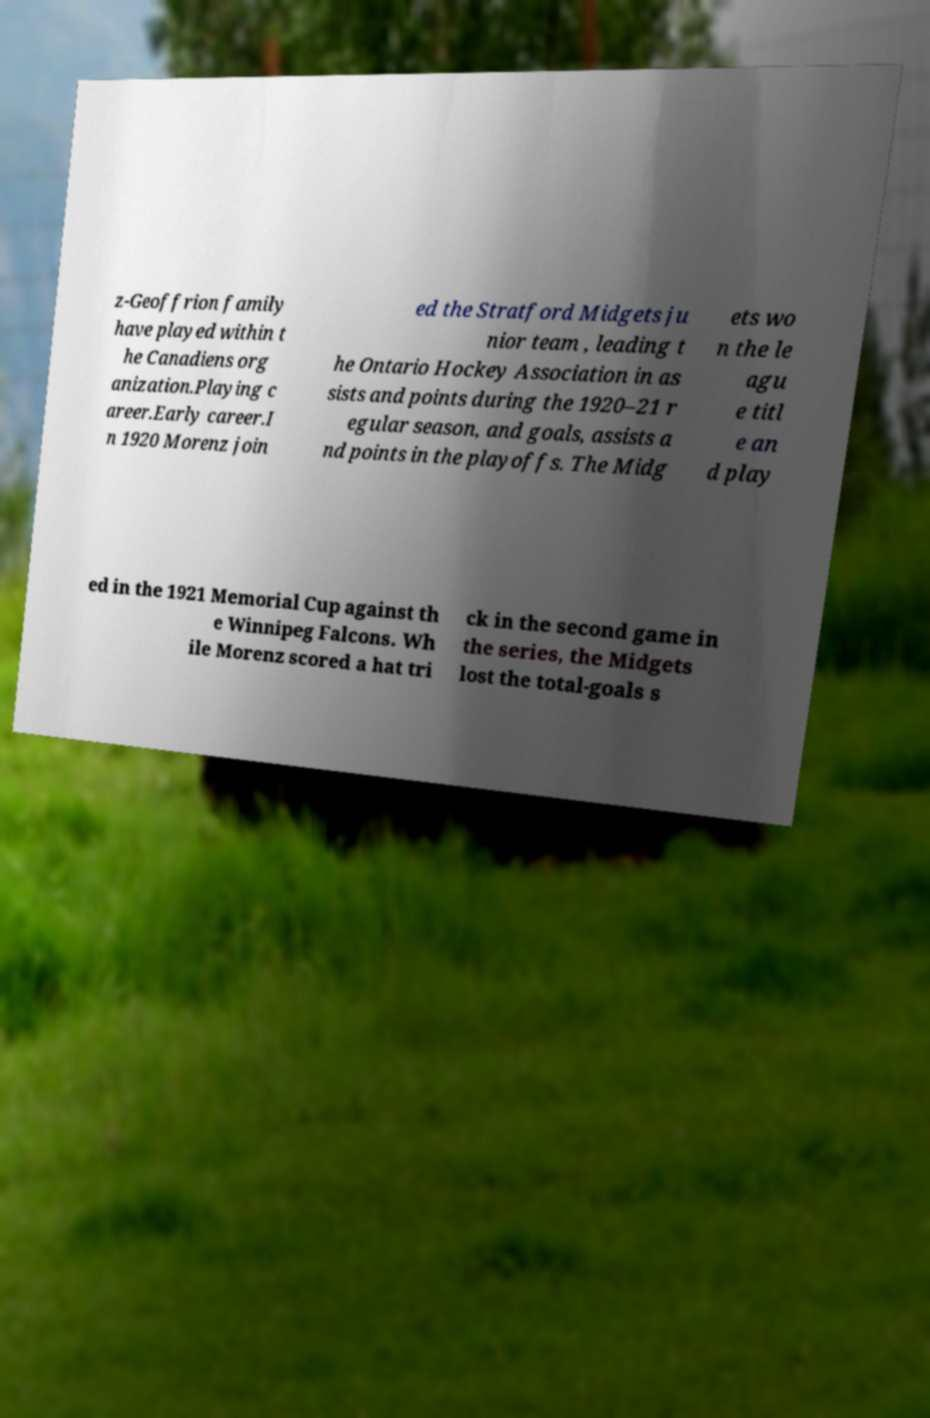For documentation purposes, I need the text within this image transcribed. Could you provide that? z-Geoffrion family have played within t he Canadiens org anization.Playing c areer.Early career.I n 1920 Morenz join ed the Stratford Midgets ju nior team , leading t he Ontario Hockey Association in as sists and points during the 1920–21 r egular season, and goals, assists a nd points in the playoffs. The Midg ets wo n the le agu e titl e an d play ed in the 1921 Memorial Cup against th e Winnipeg Falcons. Wh ile Morenz scored a hat tri ck in the second game in the series, the Midgets lost the total-goals s 